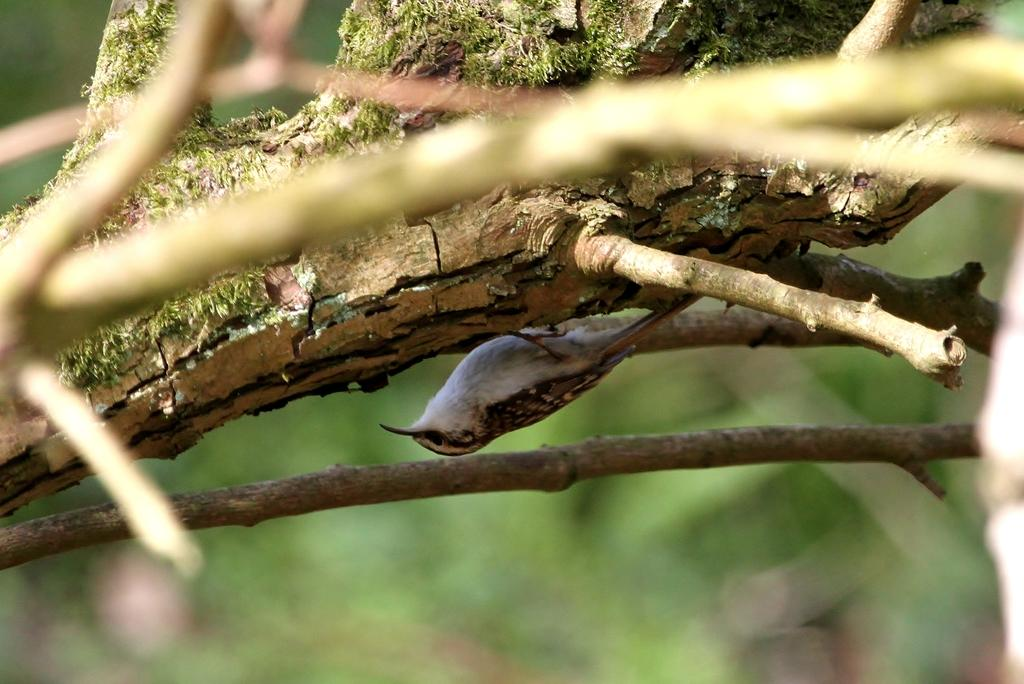What type of animal is in the image? There is a bird in the image. Where is the bird located? The bird is on a branch. Can you describe the background of the image? The background of the image is blurred. What type of watch is the bird wearing in the image? There is no watch present in the image, as birds do not wear watches. 